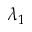<formula> <loc_0><loc_0><loc_500><loc_500>\lambda _ { 1 }</formula> 